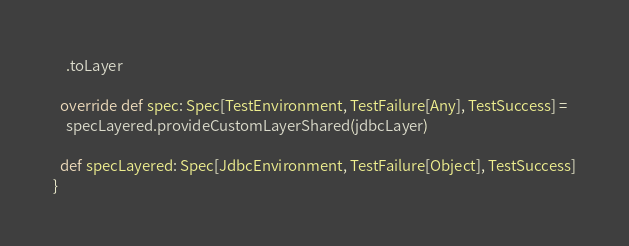Convert code to text. <code><loc_0><loc_0><loc_500><loc_500><_Scala_>    .toLayer

  override def spec: Spec[TestEnvironment, TestFailure[Any], TestSuccess] =
    specLayered.provideCustomLayerShared(jdbcLayer)

  def specLayered: Spec[JdbcEnvironment, TestFailure[Object], TestSuccess]
}
</code> 